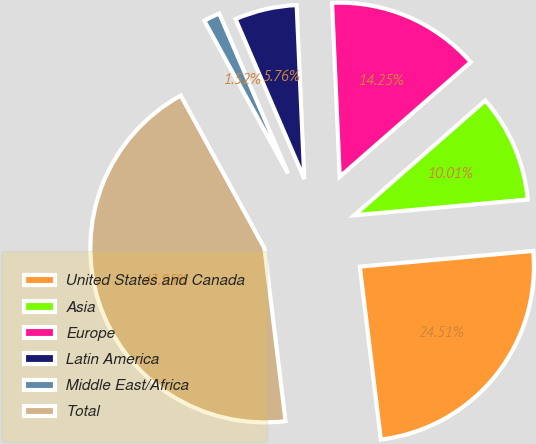<chart> <loc_0><loc_0><loc_500><loc_500><pie_chart><fcel>United States and Canada<fcel>Asia<fcel>Europe<fcel>Latin America<fcel>Middle East/Africa<fcel>Total<nl><fcel>24.51%<fcel>10.01%<fcel>14.25%<fcel>5.76%<fcel>1.52%<fcel>43.95%<nl></chart> 